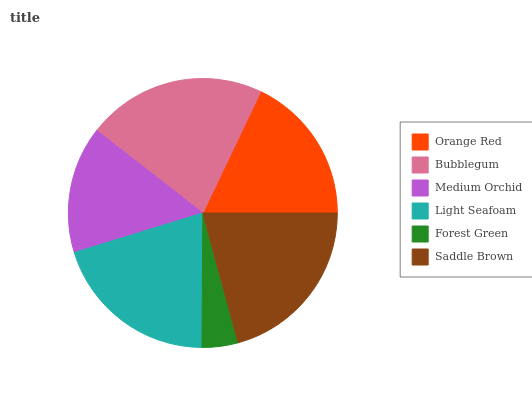Is Forest Green the minimum?
Answer yes or no. Yes. Is Bubblegum the maximum?
Answer yes or no. Yes. Is Medium Orchid the minimum?
Answer yes or no. No. Is Medium Orchid the maximum?
Answer yes or no. No. Is Bubblegum greater than Medium Orchid?
Answer yes or no. Yes. Is Medium Orchid less than Bubblegum?
Answer yes or no. Yes. Is Medium Orchid greater than Bubblegum?
Answer yes or no. No. Is Bubblegum less than Medium Orchid?
Answer yes or no. No. Is Light Seafoam the high median?
Answer yes or no. Yes. Is Orange Red the low median?
Answer yes or no. Yes. Is Medium Orchid the high median?
Answer yes or no. No. Is Medium Orchid the low median?
Answer yes or no. No. 